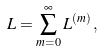Convert formula to latex. <formula><loc_0><loc_0><loc_500><loc_500>L = \sum ^ { \infty } _ { m = 0 } L ^ { ( m ) } \, ,</formula> 